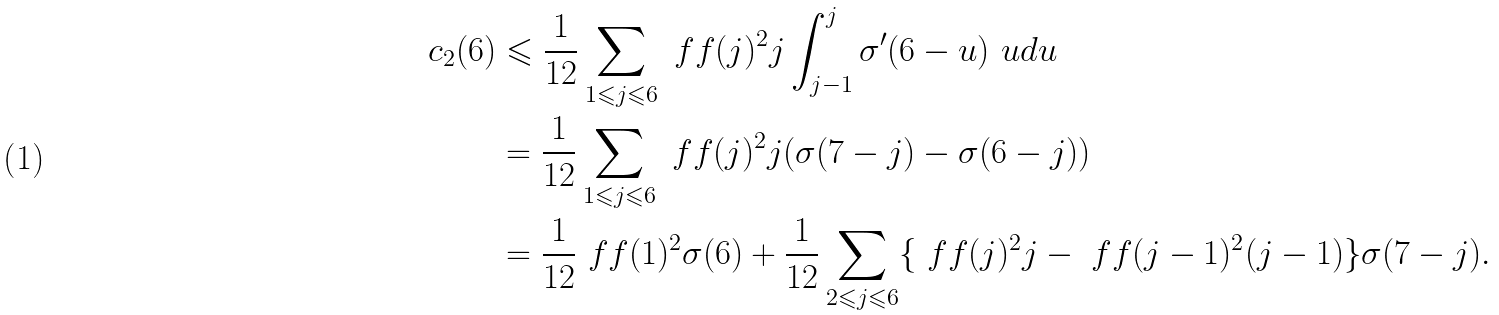Convert formula to latex. <formula><loc_0><loc_0><loc_500><loc_500>c _ { 2 } ( 6 ) & \leqslant \frac { 1 } { 1 2 } \sum _ { 1 \leqslant j \leqslant 6 } \ f f ( j ) ^ { 2 } j \int _ { j - 1 } ^ { j } \sigma ^ { \prime } ( 6 - u ) \ u d u \\ & = \frac { 1 } { 1 2 } \sum _ { 1 \leqslant j \leqslant 6 } \ f f ( j ) ^ { 2 } j ( \sigma ( 7 - j ) - \sigma ( 6 - j ) ) \\ & = \frac { 1 } { 1 2 } \ f f ( 1 ) ^ { 2 } \sigma ( 6 ) + \frac { 1 } { 1 2 } \sum _ { 2 \leqslant j \leqslant 6 } \{ \ f f ( j ) ^ { 2 } j - \ f f ( j - 1 ) ^ { 2 } ( j - 1 ) \} \sigma ( 7 - j ) .</formula> 